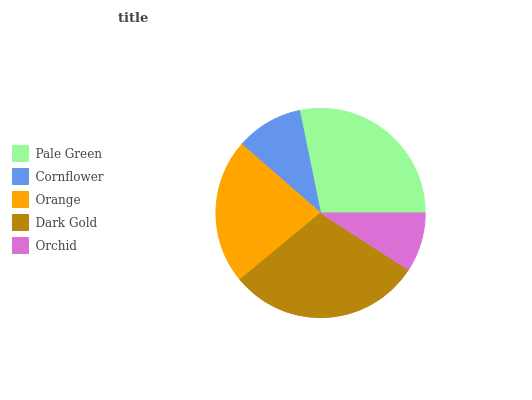Is Orchid the minimum?
Answer yes or no. Yes. Is Dark Gold the maximum?
Answer yes or no. Yes. Is Cornflower the minimum?
Answer yes or no. No. Is Cornflower the maximum?
Answer yes or no. No. Is Pale Green greater than Cornflower?
Answer yes or no. Yes. Is Cornflower less than Pale Green?
Answer yes or no. Yes. Is Cornflower greater than Pale Green?
Answer yes or no. No. Is Pale Green less than Cornflower?
Answer yes or no. No. Is Orange the high median?
Answer yes or no. Yes. Is Orange the low median?
Answer yes or no. Yes. Is Pale Green the high median?
Answer yes or no. No. Is Dark Gold the low median?
Answer yes or no. No. 